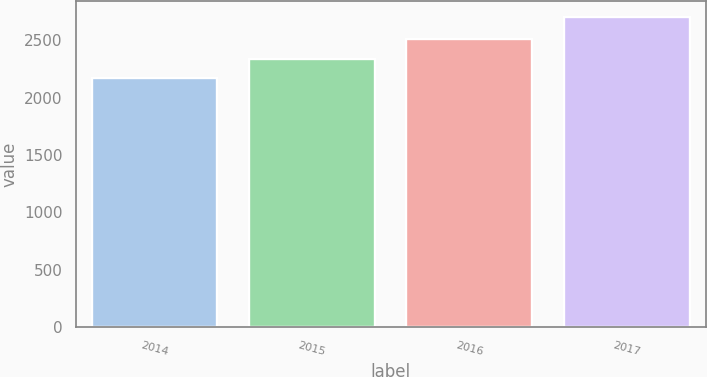Convert chart. <chart><loc_0><loc_0><loc_500><loc_500><bar_chart><fcel>2014<fcel>2015<fcel>2016<fcel>2017<nl><fcel>2170<fcel>2335<fcel>2514<fcel>2705<nl></chart> 